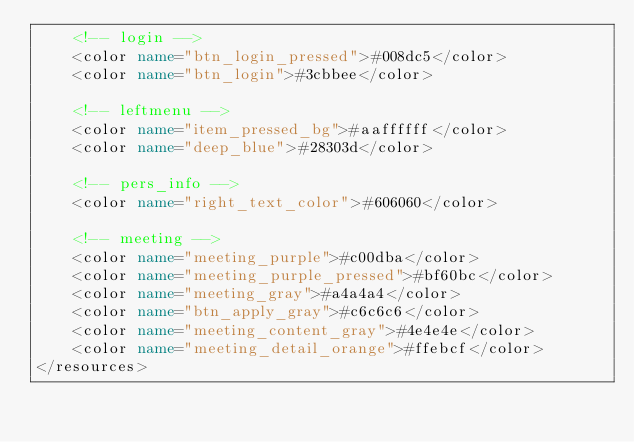<code> <loc_0><loc_0><loc_500><loc_500><_XML_>    <!-- login -->
    <color name="btn_login_pressed">#008dc5</color>
    <color name="btn_login">#3cbbee</color>
    
    <!-- leftmenu -->
    <color name="item_pressed_bg">#aaffffff</color>
    <color name="deep_blue">#28303d</color>

    <!-- pers_info -->
    <color name="right_text_color">#606060</color>
    
    <!-- meeting -->
    <color name="meeting_purple">#c00dba</color>
    <color name="meeting_purple_pressed">#bf60bc</color>
    <color name="meeting_gray">#a4a4a4</color>
    <color name="btn_apply_gray">#c6c6c6</color>
    <color name="meeting_content_gray">#4e4e4e</color>
    <color name="meeting_detail_orange">#ffebcf</color>
</resources>
</code> 